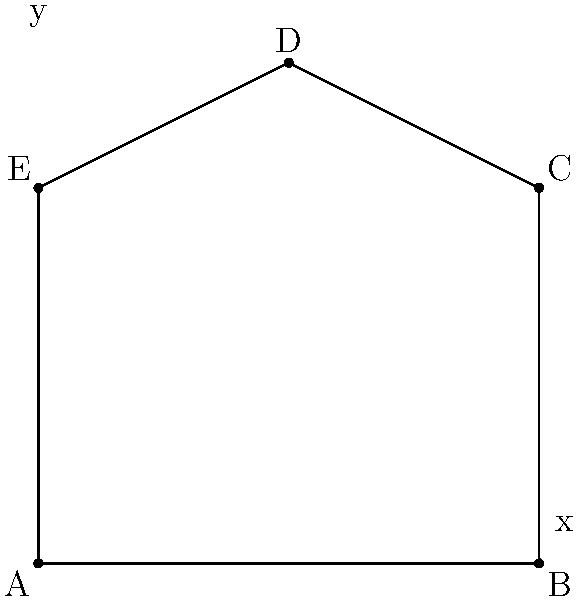Given the coordinates of a polygon ABCDE: A(0,0), B(4,0), C(4,3), D(2,4), and E(0,3), calculate its area using the shoelace formula. How would you approach this problem programmatically, considering the need for debugging and potential numerical precision issues? To solve this problem programmatically, we can follow these steps:

1. Implement the shoelace formula:
   The formula is: $$ \text{Area} = \frac{1}{2}\left|\sum_{i=1}^{n-1} (x_i y_{i+1} - x_{i+1} y_i) + (x_n y_1 - x_1 y_n)\right| $$

2. Create a function to calculate the area:
   ```python
   def polygon_area(vertices):
       n = len(vertices)
       area = 0.0
       for i in range(n):
           j = (i + 1) % n
           area += vertices[i][0] * vertices[j][1]
           area -= vertices[j][0] * vertices[i][1]
       return abs(area) / 2.0
   ```

3. Debug the function:
   - Use print statements or a debugger to check intermediate values.
   - Verify that the vertices are being accessed correctly.

4. Handle precision issues:
   - Use floating-point numbers for calculations.
   - Consider rounding the final result to a specific number of decimal places.

5. Test the function:
   ```python
   vertices = [(0,0), (4,0), (4,3), (2,4), (0,3)]
   area = polygon_area(vertices)
   print(f"Area: {area:.2f}")
   ```

6. Verify the result:
   - The polygon can be divided into a rectangle (4x3 = 12) and a triangle (1x1/2 = 0.5).
   - The expected area is 12.5 square units.

7. Optimize and refine:
   - Consider using numpy for more efficient calculations if dealing with larger polygons.
   - Implement error handling for edge cases (e.g., less than 3 vertices).

By following this approach, we can calculate the area of the polygon while addressing potential debugging and precision issues.
Answer: 12.5 square units 